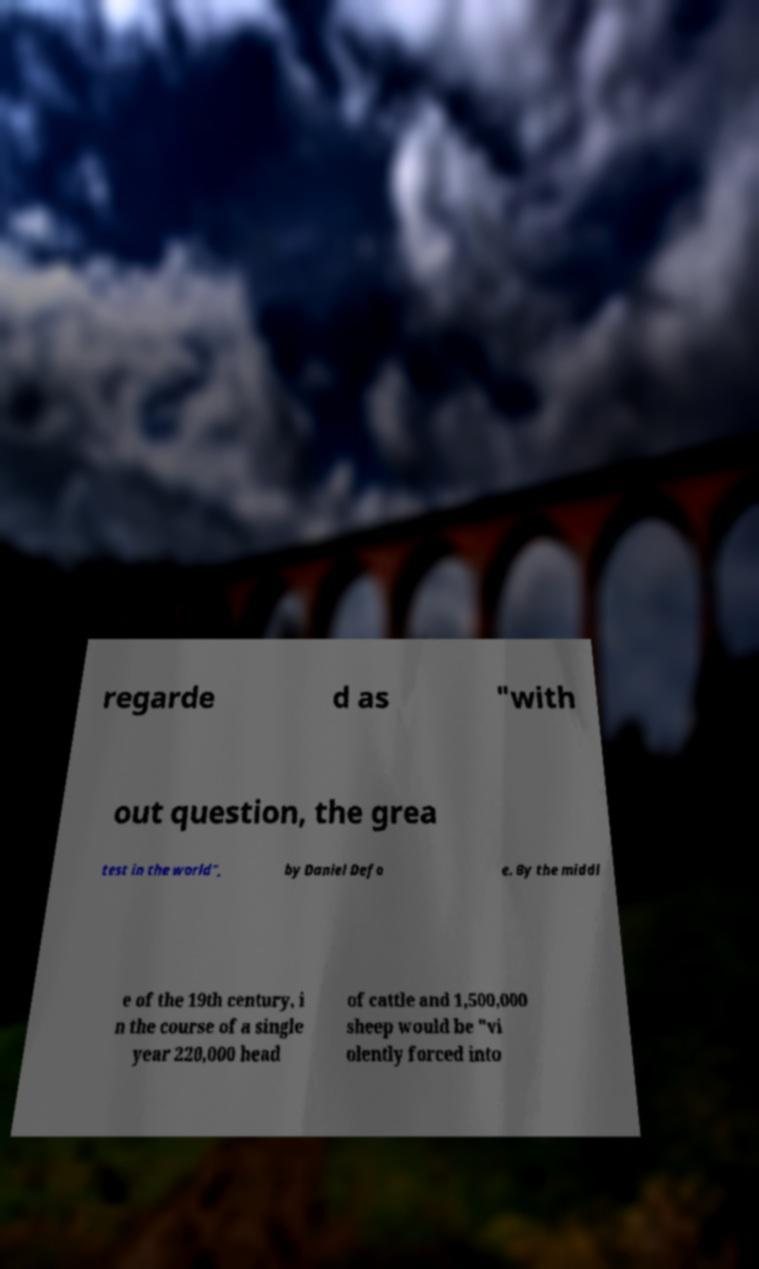Can you read and provide the text displayed in the image?This photo seems to have some interesting text. Can you extract and type it out for me? regarde d as "with out question, the grea test in the world", by Daniel Defo e. By the middl e of the 19th century, i n the course of a single year 220,000 head of cattle and 1,500,000 sheep would be "vi olently forced into 